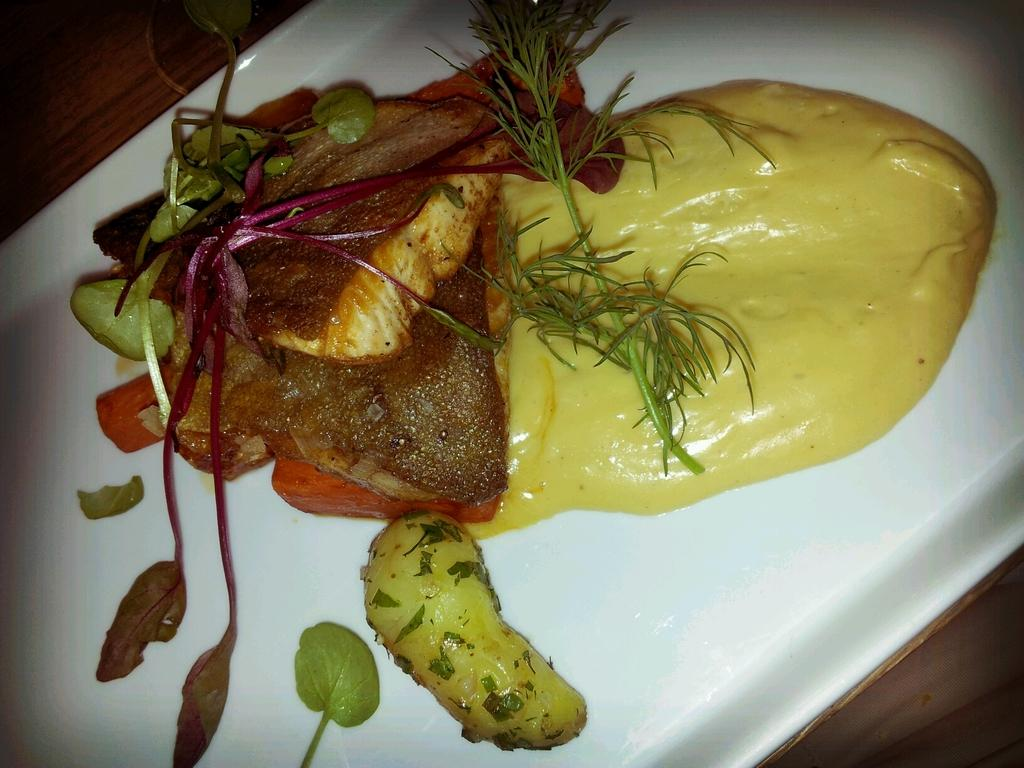What is on the plate that is visible in the image? The plate is served with food in the image. Where is the plate located in the image? The plate is placed on a table in the image. How many pins are visible on the plate in the image? There are no pins visible on the plate in the image; it is served with food. 